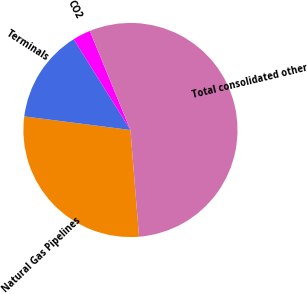<chart> <loc_0><loc_0><loc_500><loc_500><pie_chart><fcel>Natural Gas Pipelines<fcel>Terminals<fcel>CO2<fcel>Total consolidated other<nl><fcel>28.31%<fcel>14.08%<fcel>2.7%<fcel>54.91%<nl></chart> 